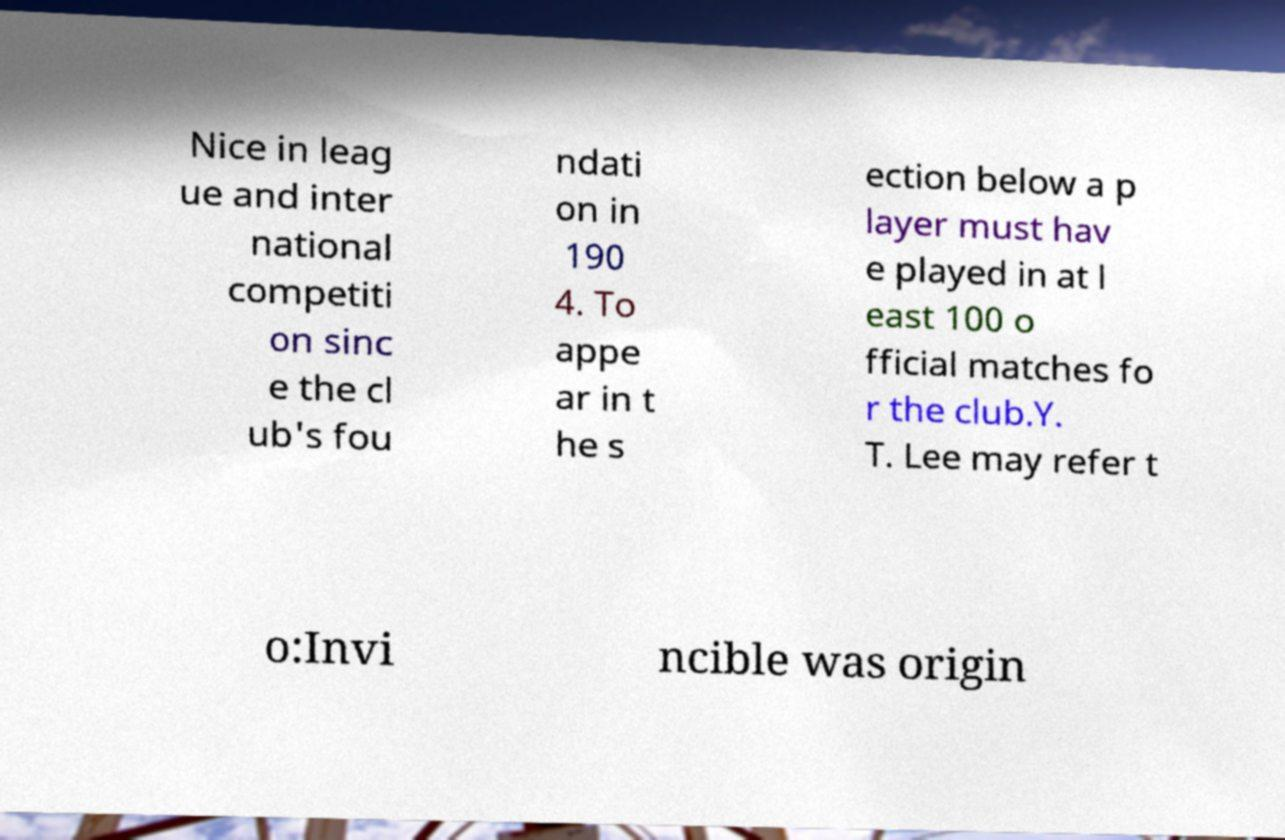For documentation purposes, I need the text within this image transcribed. Could you provide that? Nice in leag ue and inter national competiti on sinc e the cl ub's fou ndati on in 190 4. To appe ar in t he s ection below a p layer must hav e played in at l east 100 o fficial matches fo r the club.Y. T. Lee may refer t o:Invi ncible was origin 